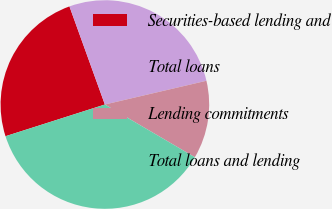Convert chart. <chart><loc_0><loc_0><loc_500><loc_500><pie_chart><fcel>Securities-based lending and<fcel>Total loans<fcel>Lending commitments<fcel>Total loans and lending<nl><fcel>24.4%<fcel>26.86%<fcel>12.09%<fcel>36.65%<nl></chart> 